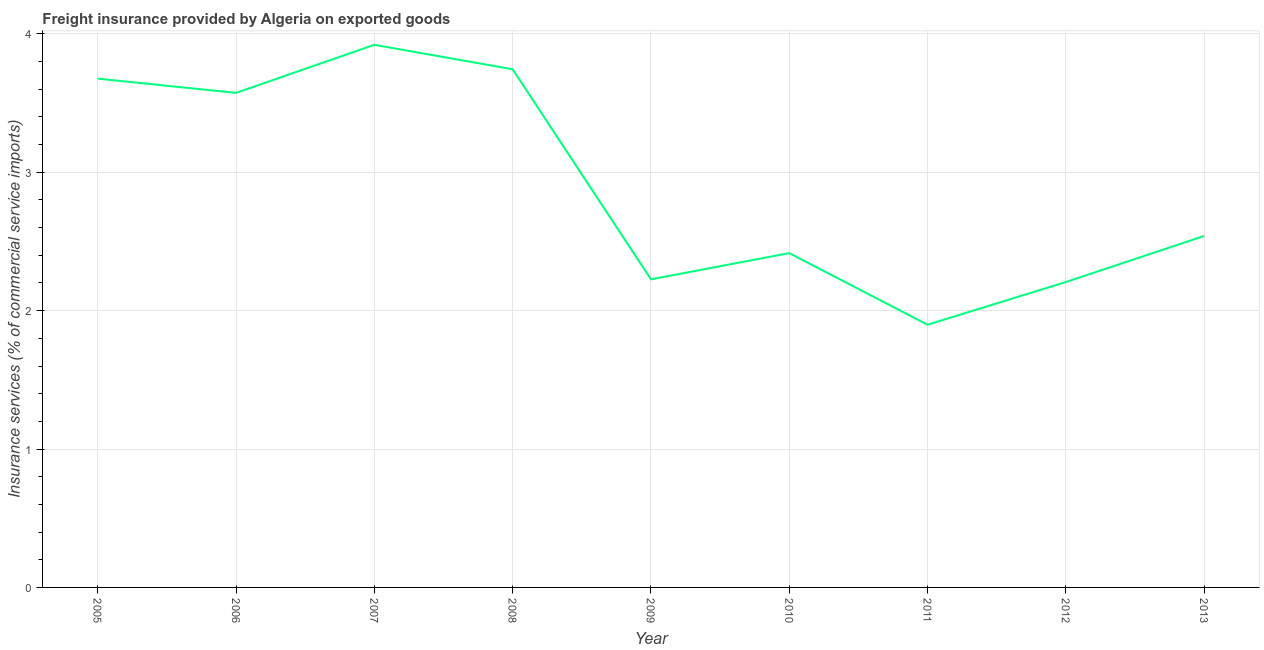What is the freight insurance in 2008?
Provide a short and direct response. 3.74. Across all years, what is the maximum freight insurance?
Keep it short and to the point. 3.92. Across all years, what is the minimum freight insurance?
Make the answer very short. 1.9. In which year was the freight insurance maximum?
Ensure brevity in your answer.  2007. What is the sum of the freight insurance?
Offer a terse response. 26.2. What is the difference between the freight insurance in 2006 and 2011?
Offer a very short reply. 1.68. What is the average freight insurance per year?
Ensure brevity in your answer.  2.91. What is the median freight insurance?
Your response must be concise. 2.54. In how many years, is the freight insurance greater than 3.2 %?
Make the answer very short. 4. What is the ratio of the freight insurance in 2005 to that in 2006?
Your response must be concise. 1.03. What is the difference between the highest and the second highest freight insurance?
Provide a succinct answer. 0.18. What is the difference between the highest and the lowest freight insurance?
Make the answer very short. 2.02. In how many years, is the freight insurance greater than the average freight insurance taken over all years?
Offer a terse response. 4. How many years are there in the graph?
Provide a succinct answer. 9. What is the difference between two consecutive major ticks on the Y-axis?
Ensure brevity in your answer.  1. Are the values on the major ticks of Y-axis written in scientific E-notation?
Make the answer very short. No. Does the graph contain any zero values?
Give a very brief answer. No. Does the graph contain grids?
Keep it short and to the point. Yes. What is the title of the graph?
Provide a succinct answer. Freight insurance provided by Algeria on exported goods . What is the label or title of the Y-axis?
Offer a terse response. Insurance services (% of commercial service imports). What is the Insurance services (% of commercial service imports) in 2005?
Provide a short and direct response. 3.68. What is the Insurance services (% of commercial service imports) of 2006?
Offer a terse response. 3.57. What is the Insurance services (% of commercial service imports) in 2007?
Offer a very short reply. 3.92. What is the Insurance services (% of commercial service imports) of 2008?
Make the answer very short. 3.74. What is the Insurance services (% of commercial service imports) in 2009?
Give a very brief answer. 2.23. What is the Insurance services (% of commercial service imports) in 2010?
Your answer should be very brief. 2.42. What is the Insurance services (% of commercial service imports) in 2011?
Your answer should be very brief. 1.9. What is the Insurance services (% of commercial service imports) in 2012?
Make the answer very short. 2.21. What is the Insurance services (% of commercial service imports) of 2013?
Your answer should be compact. 2.54. What is the difference between the Insurance services (% of commercial service imports) in 2005 and 2006?
Give a very brief answer. 0.1. What is the difference between the Insurance services (% of commercial service imports) in 2005 and 2007?
Ensure brevity in your answer.  -0.24. What is the difference between the Insurance services (% of commercial service imports) in 2005 and 2008?
Keep it short and to the point. -0.07. What is the difference between the Insurance services (% of commercial service imports) in 2005 and 2009?
Your answer should be compact. 1.45. What is the difference between the Insurance services (% of commercial service imports) in 2005 and 2010?
Provide a succinct answer. 1.26. What is the difference between the Insurance services (% of commercial service imports) in 2005 and 2011?
Your answer should be very brief. 1.78. What is the difference between the Insurance services (% of commercial service imports) in 2005 and 2012?
Make the answer very short. 1.47. What is the difference between the Insurance services (% of commercial service imports) in 2005 and 2013?
Ensure brevity in your answer.  1.14. What is the difference between the Insurance services (% of commercial service imports) in 2006 and 2007?
Your answer should be compact. -0.35. What is the difference between the Insurance services (% of commercial service imports) in 2006 and 2008?
Provide a succinct answer. -0.17. What is the difference between the Insurance services (% of commercial service imports) in 2006 and 2009?
Offer a very short reply. 1.35. What is the difference between the Insurance services (% of commercial service imports) in 2006 and 2010?
Make the answer very short. 1.16. What is the difference between the Insurance services (% of commercial service imports) in 2006 and 2011?
Your answer should be compact. 1.68. What is the difference between the Insurance services (% of commercial service imports) in 2006 and 2012?
Offer a very short reply. 1.37. What is the difference between the Insurance services (% of commercial service imports) in 2006 and 2013?
Your answer should be very brief. 1.03. What is the difference between the Insurance services (% of commercial service imports) in 2007 and 2008?
Your response must be concise. 0.18. What is the difference between the Insurance services (% of commercial service imports) in 2007 and 2009?
Offer a terse response. 1.69. What is the difference between the Insurance services (% of commercial service imports) in 2007 and 2010?
Keep it short and to the point. 1.51. What is the difference between the Insurance services (% of commercial service imports) in 2007 and 2011?
Provide a succinct answer. 2.02. What is the difference between the Insurance services (% of commercial service imports) in 2007 and 2012?
Make the answer very short. 1.71. What is the difference between the Insurance services (% of commercial service imports) in 2007 and 2013?
Give a very brief answer. 1.38. What is the difference between the Insurance services (% of commercial service imports) in 2008 and 2009?
Give a very brief answer. 1.52. What is the difference between the Insurance services (% of commercial service imports) in 2008 and 2010?
Give a very brief answer. 1.33. What is the difference between the Insurance services (% of commercial service imports) in 2008 and 2011?
Offer a very short reply. 1.85. What is the difference between the Insurance services (% of commercial service imports) in 2008 and 2012?
Offer a terse response. 1.54. What is the difference between the Insurance services (% of commercial service imports) in 2008 and 2013?
Your response must be concise. 1.2. What is the difference between the Insurance services (% of commercial service imports) in 2009 and 2010?
Ensure brevity in your answer.  -0.19. What is the difference between the Insurance services (% of commercial service imports) in 2009 and 2011?
Keep it short and to the point. 0.33. What is the difference between the Insurance services (% of commercial service imports) in 2009 and 2012?
Your answer should be very brief. 0.02. What is the difference between the Insurance services (% of commercial service imports) in 2009 and 2013?
Ensure brevity in your answer.  -0.31. What is the difference between the Insurance services (% of commercial service imports) in 2010 and 2011?
Your response must be concise. 0.52. What is the difference between the Insurance services (% of commercial service imports) in 2010 and 2012?
Provide a short and direct response. 0.21. What is the difference between the Insurance services (% of commercial service imports) in 2010 and 2013?
Your answer should be compact. -0.12. What is the difference between the Insurance services (% of commercial service imports) in 2011 and 2012?
Keep it short and to the point. -0.31. What is the difference between the Insurance services (% of commercial service imports) in 2011 and 2013?
Provide a succinct answer. -0.64. What is the difference between the Insurance services (% of commercial service imports) in 2012 and 2013?
Your answer should be compact. -0.33. What is the ratio of the Insurance services (% of commercial service imports) in 2005 to that in 2007?
Provide a short and direct response. 0.94. What is the ratio of the Insurance services (% of commercial service imports) in 2005 to that in 2008?
Make the answer very short. 0.98. What is the ratio of the Insurance services (% of commercial service imports) in 2005 to that in 2009?
Offer a terse response. 1.65. What is the ratio of the Insurance services (% of commercial service imports) in 2005 to that in 2010?
Offer a very short reply. 1.52. What is the ratio of the Insurance services (% of commercial service imports) in 2005 to that in 2011?
Keep it short and to the point. 1.94. What is the ratio of the Insurance services (% of commercial service imports) in 2005 to that in 2012?
Your response must be concise. 1.67. What is the ratio of the Insurance services (% of commercial service imports) in 2005 to that in 2013?
Keep it short and to the point. 1.45. What is the ratio of the Insurance services (% of commercial service imports) in 2006 to that in 2007?
Offer a terse response. 0.91. What is the ratio of the Insurance services (% of commercial service imports) in 2006 to that in 2008?
Offer a very short reply. 0.95. What is the ratio of the Insurance services (% of commercial service imports) in 2006 to that in 2009?
Keep it short and to the point. 1.6. What is the ratio of the Insurance services (% of commercial service imports) in 2006 to that in 2010?
Give a very brief answer. 1.48. What is the ratio of the Insurance services (% of commercial service imports) in 2006 to that in 2011?
Offer a terse response. 1.88. What is the ratio of the Insurance services (% of commercial service imports) in 2006 to that in 2012?
Provide a succinct answer. 1.62. What is the ratio of the Insurance services (% of commercial service imports) in 2006 to that in 2013?
Offer a terse response. 1.41. What is the ratio of the Insurance services (% of commercial service imports) in 2007 to that in 2008?
Offer a very short reply. 1.05. What is the ratio of the Insurance services (% of commercial service imports) in 2007 to that in 2009?
Make the answer very short. 1.76. What is the ratio of the Insurance services (% of commercial service imports) in 2007 to that in 2010?
Keep it short and to the point. 1.62. What is the ratio of the Insurance services (% of commercial service imports) in 2007 to that in 2011?
Ensure brevity in your answer.  2.06. What is the ratio of the Insurance services (% of commercial service imports) in 2007 to that in 2012?
Offer a terse response. 1.78. What is the ratio of the Insurance services (% of commercial service imports) in 2007 to that in 2013?
Make the answer very short. 1.54. What is the ratio of the Insurance services (% of commercial service imports) in 2008 to that in 2009?
Your answer should be very brief. 1.68. What is the ratio of the Insurance services (% of commercial service imports) in 2008 to that in 2010?
Provide a short and direct response. 1.55. What is the ratio of the Insurance services (% of commercial service imports) in 2008 to that in 2011?
Ensure brevity in your answer.  1.97. What is the ratio of the Insurance services (% of commercial service imports) in 2008 to that in 2012?
Provide a succinct answer. 1.7. What is the ratio of the Insurance services (% of commercial service imports) in 2008 to that in 2013?
Offer a terse response. 1.47. What is the ratio of the Insurance services (% of commercial service imports) in 2009 to that in 2010?
Make the answer very short. 0.92. What is the ratio of the Insurance services (% of commercial service imports) in 2009 to that in 2011?
Provide a succinct answer. 1.17. What is the ratio of the Insurance services (% of commercial service imports) in 2009 to that in 2013?
Your response must be concise. 0.88. What is the ratio of the Insurance services (% of commercial service imports) in 2010 to that in 2011?
Your response must be concise. 1.27. What is the ratio of the Insurance services (% of commercial service imports) in 2010 to that in 2012?
Offer a very short reply. 1.09. What is the ratio of the Insurance services (% of commercial service imports) in 2010 to that in 2013?
Give a very brief answer. 0.95. What is the ratio of the Insurance services (% of commercial service imports) in 2011 to that in 2012?
Provide a short and direct response. 0.86. What is the ratio of the Insurance services (% of commercial service imports) in 2011 to that in 2013?
Offer a terse response. 0.75. What is the ratio of the Insurance services (% of commercial service imports) in 2012 to that in 2013?
Offer a very short reply. 0.87. 